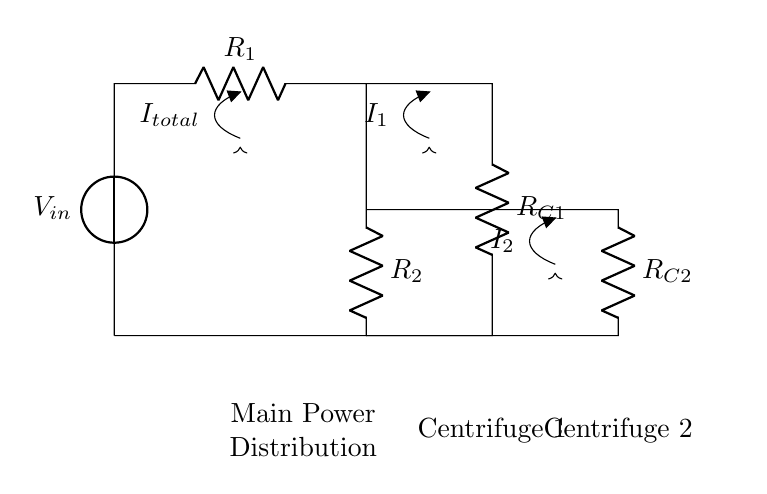What is the input voltage in this circuit? The input voltage is labeled as \( V_{in} \) at the voltage source on the left side of the circuit.
Answer: \( V_{in} \) What are the two resistors connected to the current divider? The two resistors connected to the current divider are \( R_1 \) and \( R_2 \). \( R_1 \) is located in series with the voltage source, while \( R_2 \) is connected to the output to the centrifuges from the junction.
Answer: \( R_1 \) and \( R_2 \) How many centrifuges are powered by this circuit? There are two centrifuges powered by this circuit. The drawing indicates Centrifuge 1 and Centrifuge 2 as distinct outputs from the current divider.
Answer: 2 What is the direction of the total current flow in the circuit? The total current, indicated as \( I_{total} \), flows from the voltage source \( V_{in} \) through \( R_1 \) to the junction, then splits towards \( R_{C1} \) and \( R_{C2} \).
Answer: Downwards How does \( I_{1} \) and \( I_{2} \) relate to \( I_{total} \)? In a current divider, the total current \( I_{total} \) is the sum of currents \( I_1 \) and \( I_2 \). Hence, \( I_{total} = I_1 + I_2 \). This reflects the principle of current division based on resistance values.
Answer: \( I_{total} = I_1 + I_2 \) What happens to the current when \( R_{C1} \) is less than \( R_{C2} \)? If \( R_{C1} \) is less than \( R_{C2} \), then more current will flow through \( R_{C1} \) compared to \( R_{C2} \). The current division principle states that current is inversely proportional to resistance.
Answer: More current through \( R_{C1} \) What is the purpose of this current splitting circuit in a laboratory centrifuge? The purpose of this current splitting circuit is to regulate power distribution to the different centrifuge units, allowing them to operate simultaneously while receiving a proportional amount of current based on their resistor values.
Answer: Power distribution 